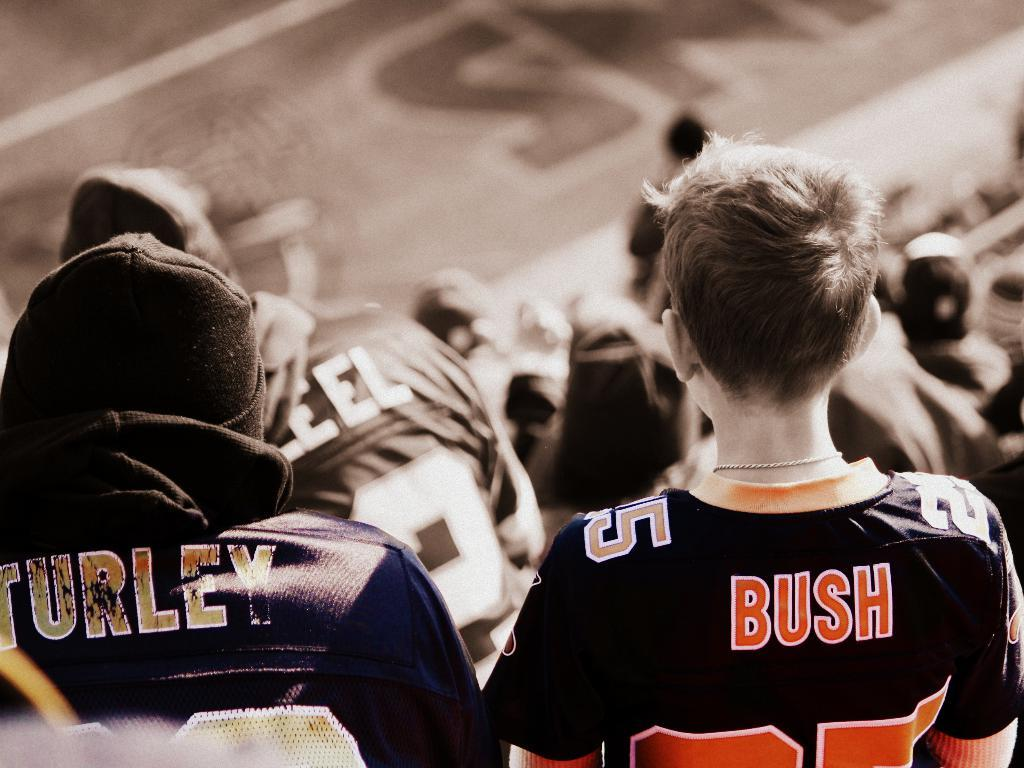Provide a one-sentence caption for the provided image. two people in a crowd with Bush and Turley jerseys on. 